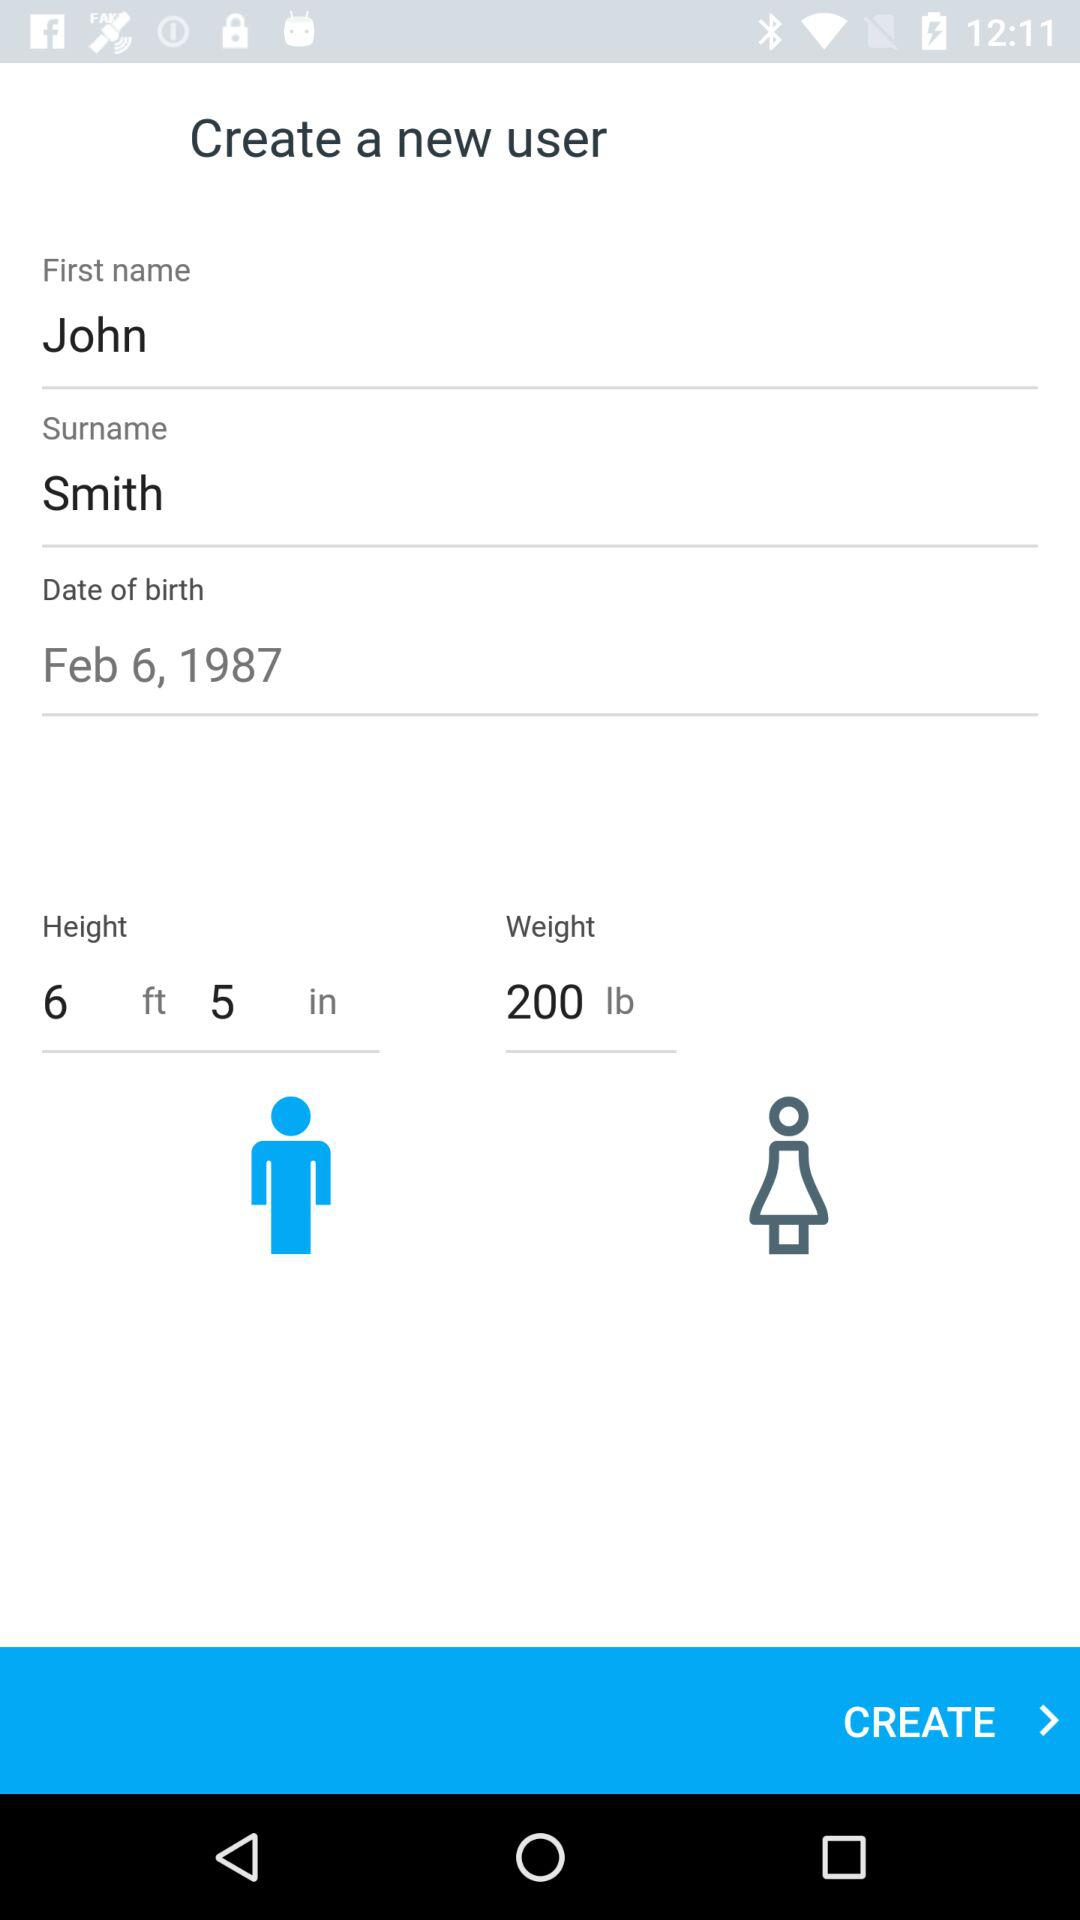What is the height? The height is 6 feet 5 inches. 